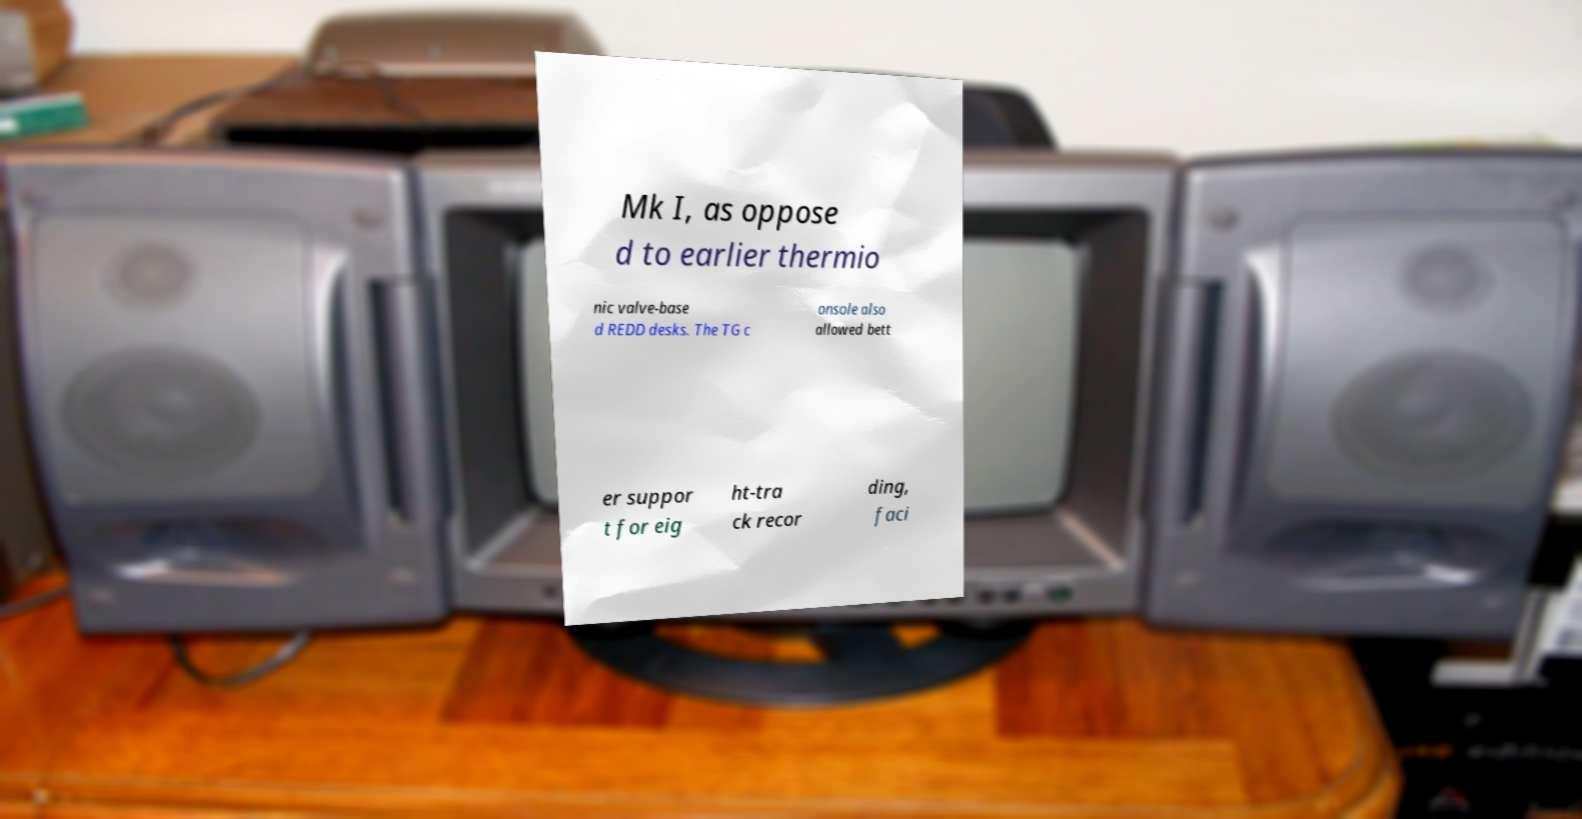For documentation purposes, I need the text within this image transcribed. Could you provide that? Mk I, as oppose d to earlier thermio nic valve-base d REDD desks. The TG c onsole also allowed bett er suppor t for eig ht-tra ck recor ding, faci 